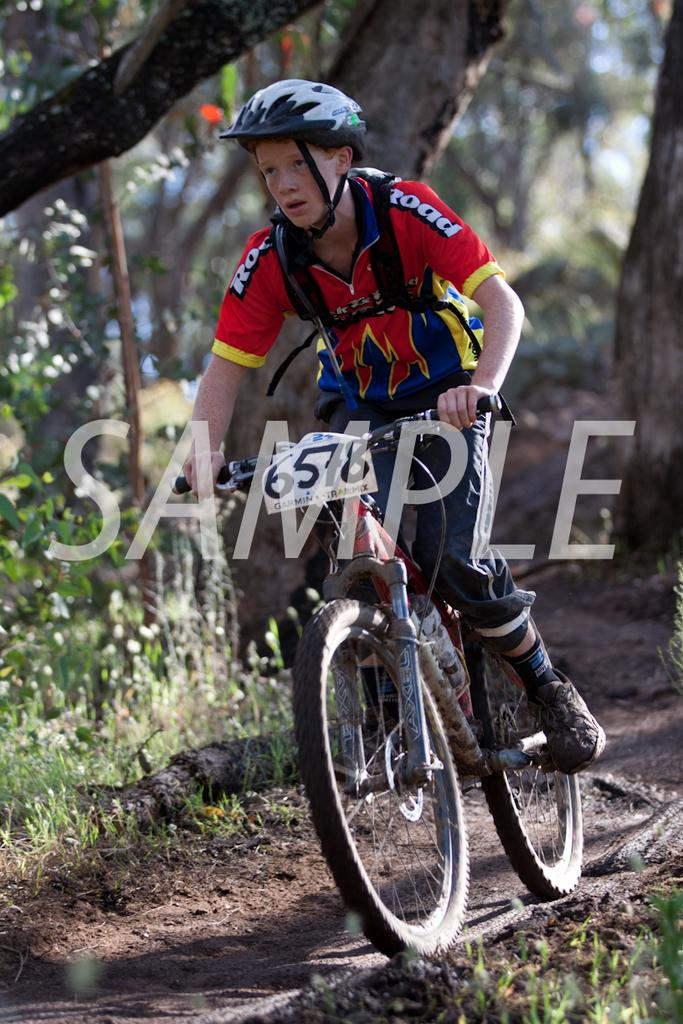Where was the image taken? The image is taken outdoors. What is the person in the image wearing? The person is wearing a red t-shirt. What activity is the person in the image engaged in? The person is riding a bicycle. What can be seen in the background of the image? There is a tree in the background of the image. What type of vegetable is the person holding in the image? There is no vegetable present in the image; the person is riding a bicycle. Can you tell me how many hands the person has in the image? The image does not show the person's hands, so it is impossible to determine the number of hands they have. 